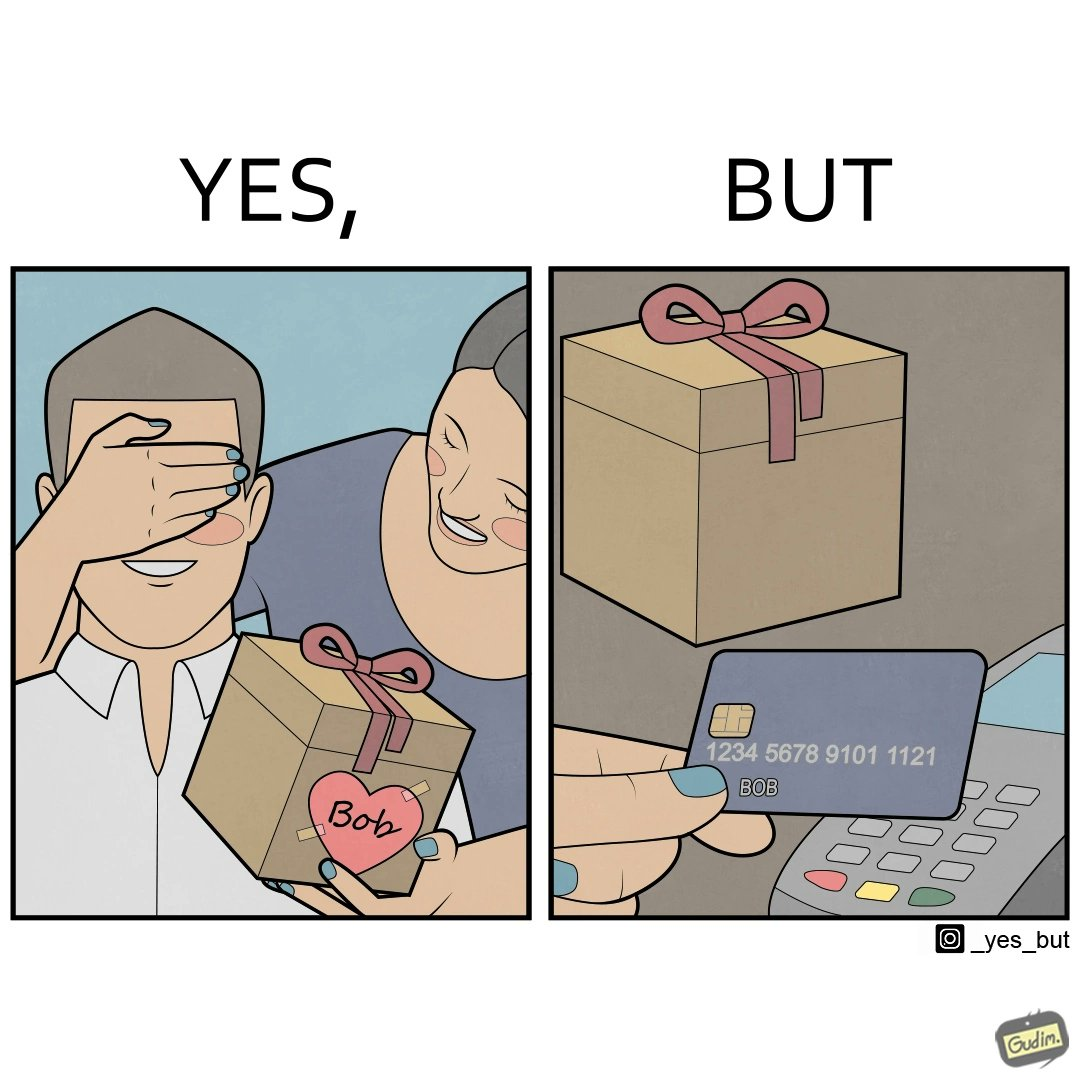Describe the satirical element in this image. The image is ironical, as a woman is gifting something to a person named Bob, while using Bob's card itself to purchase the gift. 